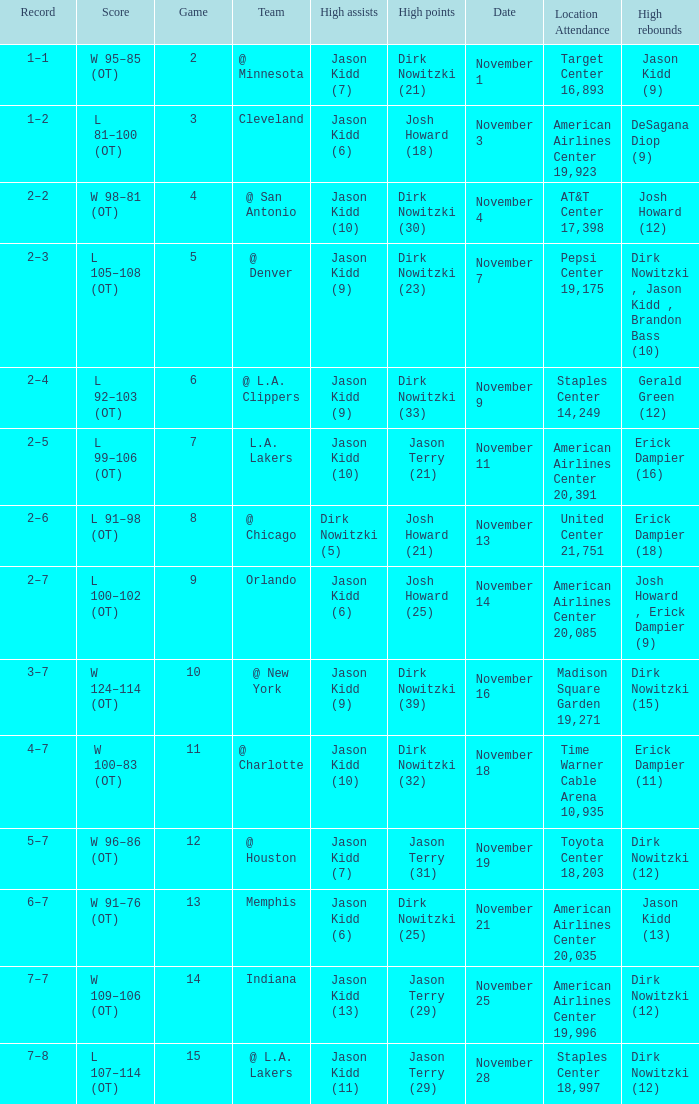What was the record on November 7? 1.0. 